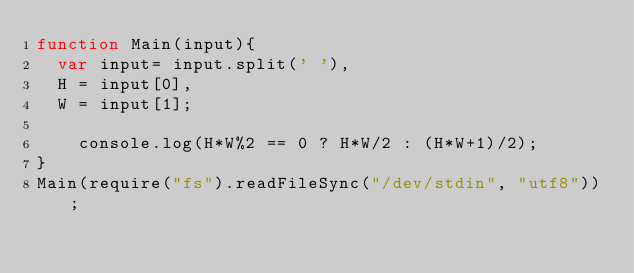<code> <loc_0><loc_0><loc_500><loc_500><_JavaScript_>function Main(input){
	var input= input.split(' '),
	H = input[0],
	W = input[1];

		console.log(H*W%2 == 0 ? H*W/2 : (H*W+1)/2);
}
Main(require("fs").readFileSync("/dev/stdin", "utf8"));</code> 